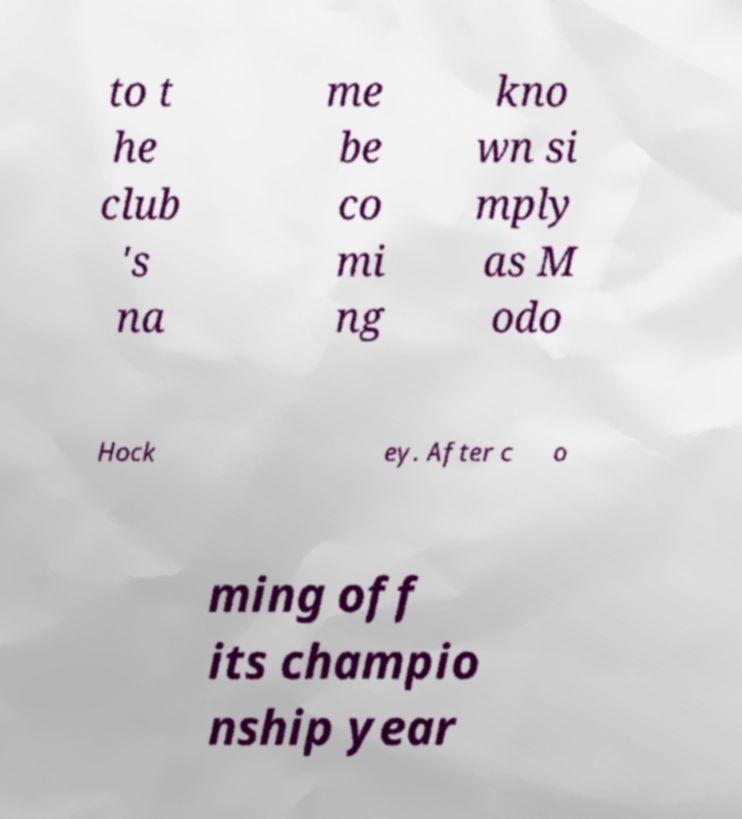Can you accurately transcribe the text from the provided image for me? to t he club 's na me be co mi ng kno wn si mply as M odo Hock ey. After c o ming off its champio nship year 